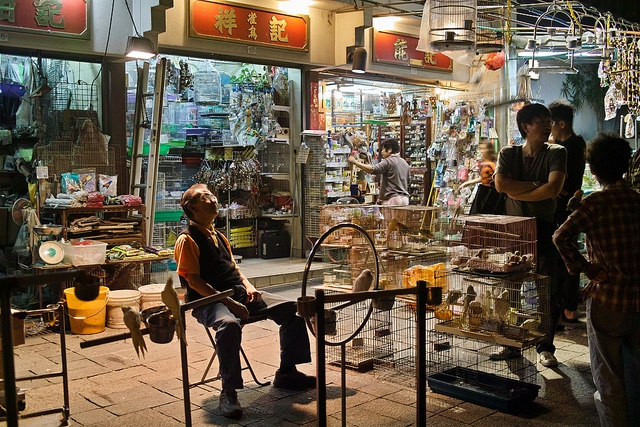Describe the objects in this image and their specific colors. I can see people in darkgreen, black, maroon, and gray tones, people in darkgreen, black, maroon, and gray tones, people in darkgreen, black, maroon, and darkgray tones, people in darkgreen, black, maroon, and gray tones, and people in darkgreen, black, darkgray, and gray tones in this image. 